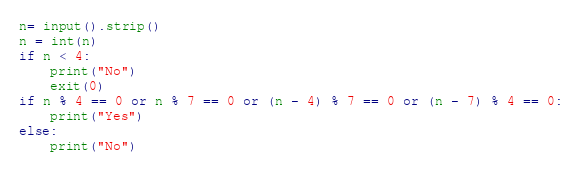<code> <loc_0><loc_0><loc_500><loc_500><_Python_>n= input().strip()
n = int(n)
if n < 4:
    print("No")
    exit(0)
if n % 4 == 0 or n % 7 == 0 or (n - 4) % 7 == 0 or (n - 7) % 4 == 0:
    print("Yes")
else:
    print("No")</code> 